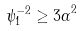Convert formula to latex. <formula><loc_0><loc_0><loc_500><loc_500>\psi _ { 1 } ^ { - 2 } \geq { 3 \alpha } ^ { 2 }</formula> 